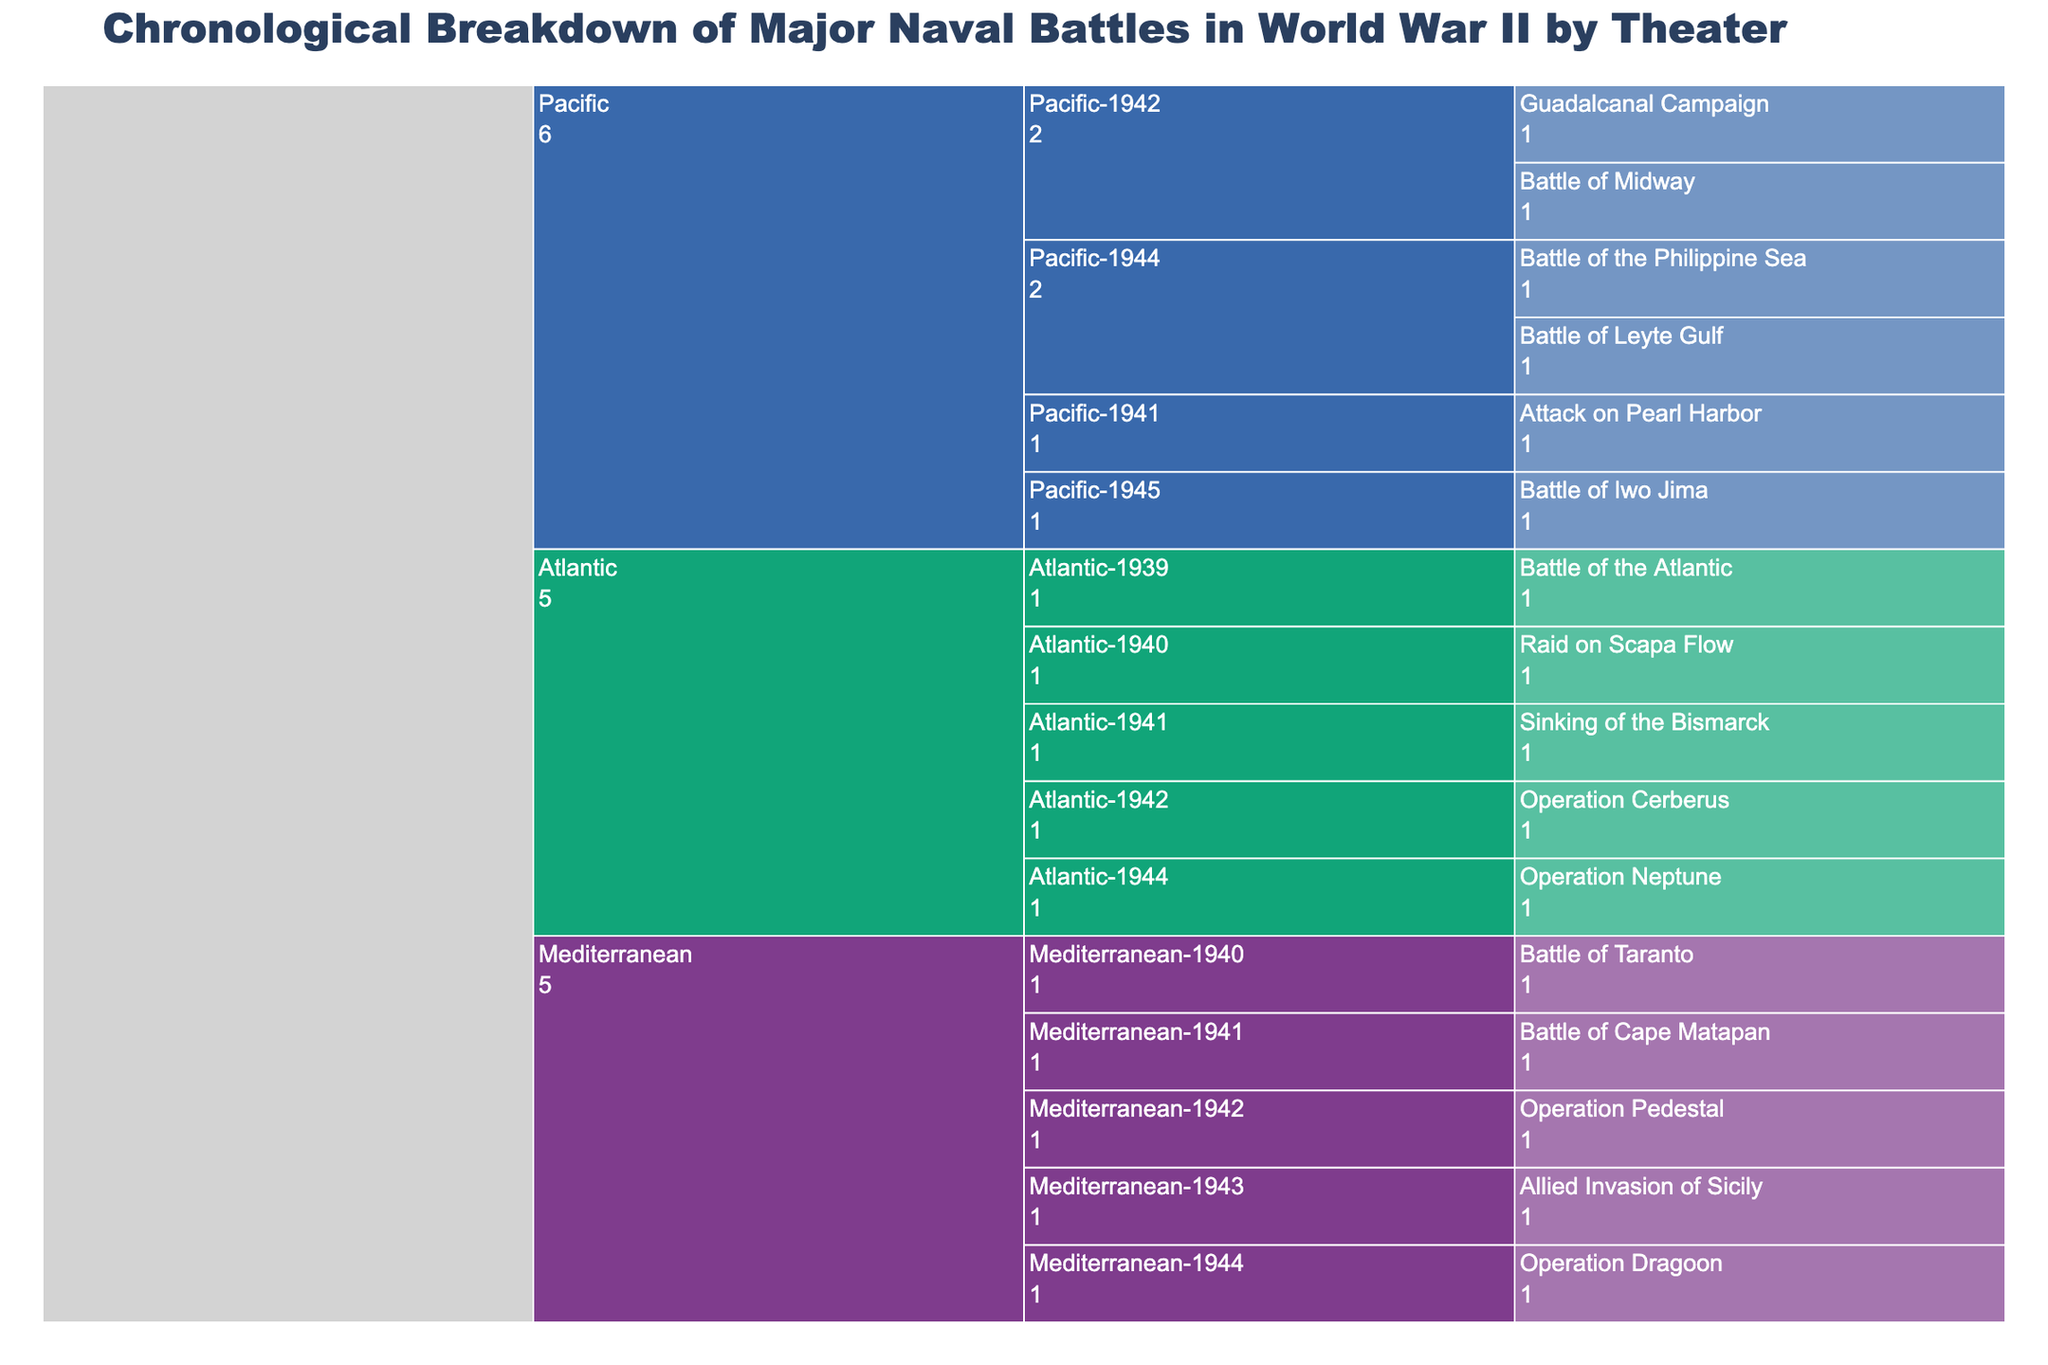Which theater and year saw the highest number of naval battles? The Pacific theater in 1944 saw two major naval battles: the Battle of the Philippine Sea and the Battle of Leyte Gulf. This is indicated by the fact that both battles are next to the Pacific-1944 segment, which is larger compared to others.
Answer: Pacific, 1944 How many major naval battles occurred in the Atlantic theater? Count each branch under the Atlantic segment. There are five battles listed: Battle of the Atlantic, Raid on Scapa Flow, Sinking of the Bismarck, Operation Cerberus, and Operation Neptune.
Answer: 5 Which battle was the earliest major naval battle listed in the Mediterranean theater? By checking the chronological breakdown in the Mediterranean segment, the Battle of Taranto in 1940 is the earliest.
Answer: Battle of Taranto Compare the number of naval battles in the Mediterranean and Atlantic theaters: which one had more battles? The Atlantic theater has five battles listed, while the Mediterranean theater has five battles. Therefore, both theaters had the same number of battles.
Answer: Same number of battles What is the title of the Icicle chart? The title is at the top of the chart and reads "Chronological Breakdown of Major Naval Battles in World War II by Theater".
Answer: Chronological Breakdown of Major Naval Battles in World War II by Theater In which year did the Pacific theater experience its first listed major naval battle? By examining the chronological hierarchy within the Pacific segment, the first battle is the Attack on Pearl Harbor, which occurred in 1941.
Answer: 1941 How many theaters are represented in the Icicle chart? There are three top-level segments in the chart, each representing a different theater: Pacific, Atlantic, and Mediterranean.
Answer: 3 Which naval battle occurred during the same year as the Battle of Midway in the Pacific theater? Looking at the chart, the Guadalcanal Campaign also occurred in 1942 in the Pacific theater.
Answer: Guadalcanal Campaign What is the only battle listed for 1945, and which theater is it in? The only battle listed for 1945 is the Battle of Iwo Jima, which is in the Pacific theater.
Answer: Battle of Iwo Jima, Pacific Identify the major naval battle from the Atlantic theater that occurred in the year 1939. Under the Atlantic-1939 segment, the Battle of the Atlantic is listed as the battle for that year.
Answer: Battle of the Atlantic 